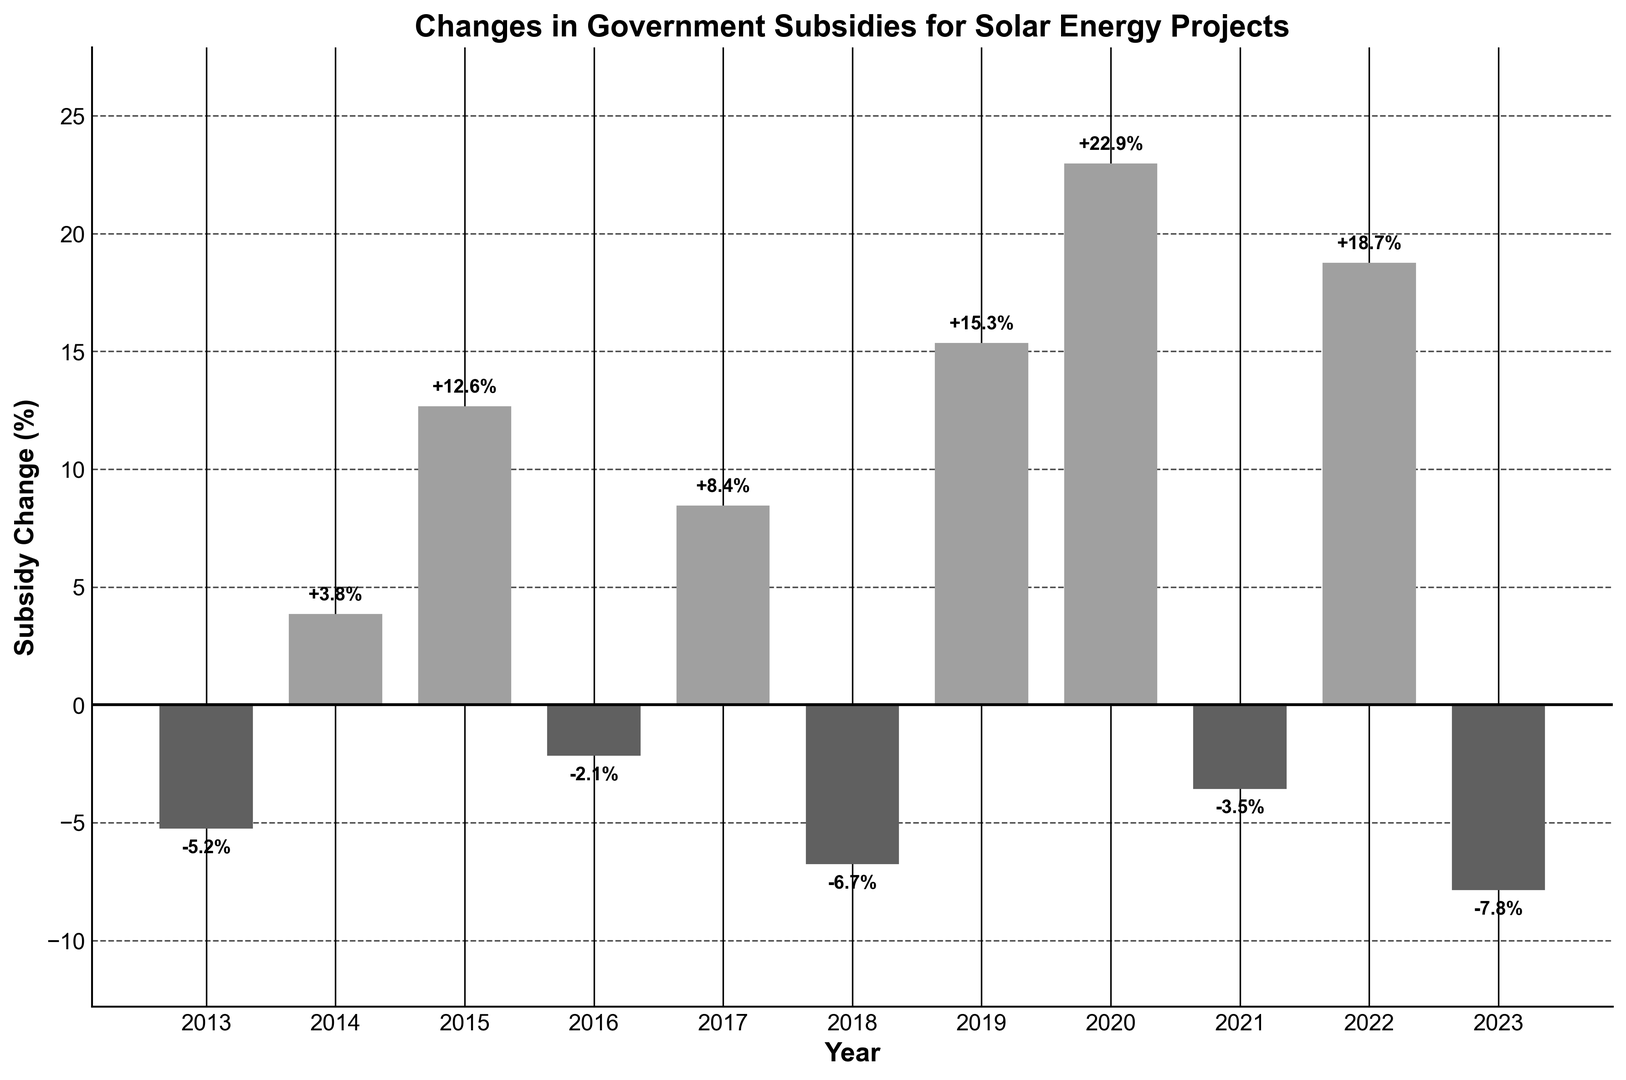Which year had the highest positive change in subsidies? To find the highest positive change, look at the heights of the bars above the zero line. The tallest bar above zero corresponds to the year 2020, with a subsidy change of 22.9%.
Answer: 2020 Which year had the lowest negative change in subsidies? To find the lowest negative change, look at the heights of the bars below the zero line. The lowest bar below zero corresponds to the year 2023, with a subsidy change of -7.8%.
Answer: 2023 How many years experienced a negative change in subsidies? Count the bars that extend below the zero line. There are four bars (2013, 2016, 2018, 2021, and 2023) indicating negative changes.
Answer: 5 What is the average subsidy change over the past decade? Sum up all the values and divide by the number of years: (-5.2 + 3.8 + 12.6 + -2.1 + 8.4 + -6.7 + 15.3 + 22.9 + -3.5 + 18.7 + -7.8) / 11 = 56.4 / 11 ≈ 5.13%.
Answer: 5.13% Which year had a higher subsidy change: 2017 or 2022? Compare the heights of the bars for 2017 and 2022. The bar for 2022 (18.7%) is taller than that for 2017 (8.4%).
Answer: 2022 What is the total change in subsidies over the past 5 years? Add the values from 2019 to 2023: 15.3 + 22.9 + -3.5 + 18.7 + -7.8 = 45.6%.
Answer: 45.6% Which year had a subsidy change closer to zero, 2014 or 2016? Compare the absolute values of the changes: 2014 (3.8%) and 2016 (-2.1%). The smaller absolute value indicates a change closer to zero, which is 2016.
Answer: 2016 Identify all years when the subsidy change was less than -5%. Look at the bars below the zero line and find those less than -5%. The years are 2013 (-5.2%), 2018 (-6.7%), and 2023 (-7.8%).
Answer: 2013, 2018, 2023 What is the difference in subsidy changes between 2019 and 2023? Subtract the value for 2023 from the value for 2019: 15.3 - (-7.8) = 15.3 + 7.8 = 23.1%.
Answer: 23.1% Describe the overall trend in government subsidies for solar energy projects from 2013 to 2023. The pattern shows an overall fluctuation with both positive and negative changes. Significant increases are seen in 2015, 2019, 2020, and 2022, while notable decreases occur in 2013, 2018, and 2023. The recent half-decade shows an overall increase despite yearly variations.
Answer: Fluctuating, with a trend of significant increases and decreases 